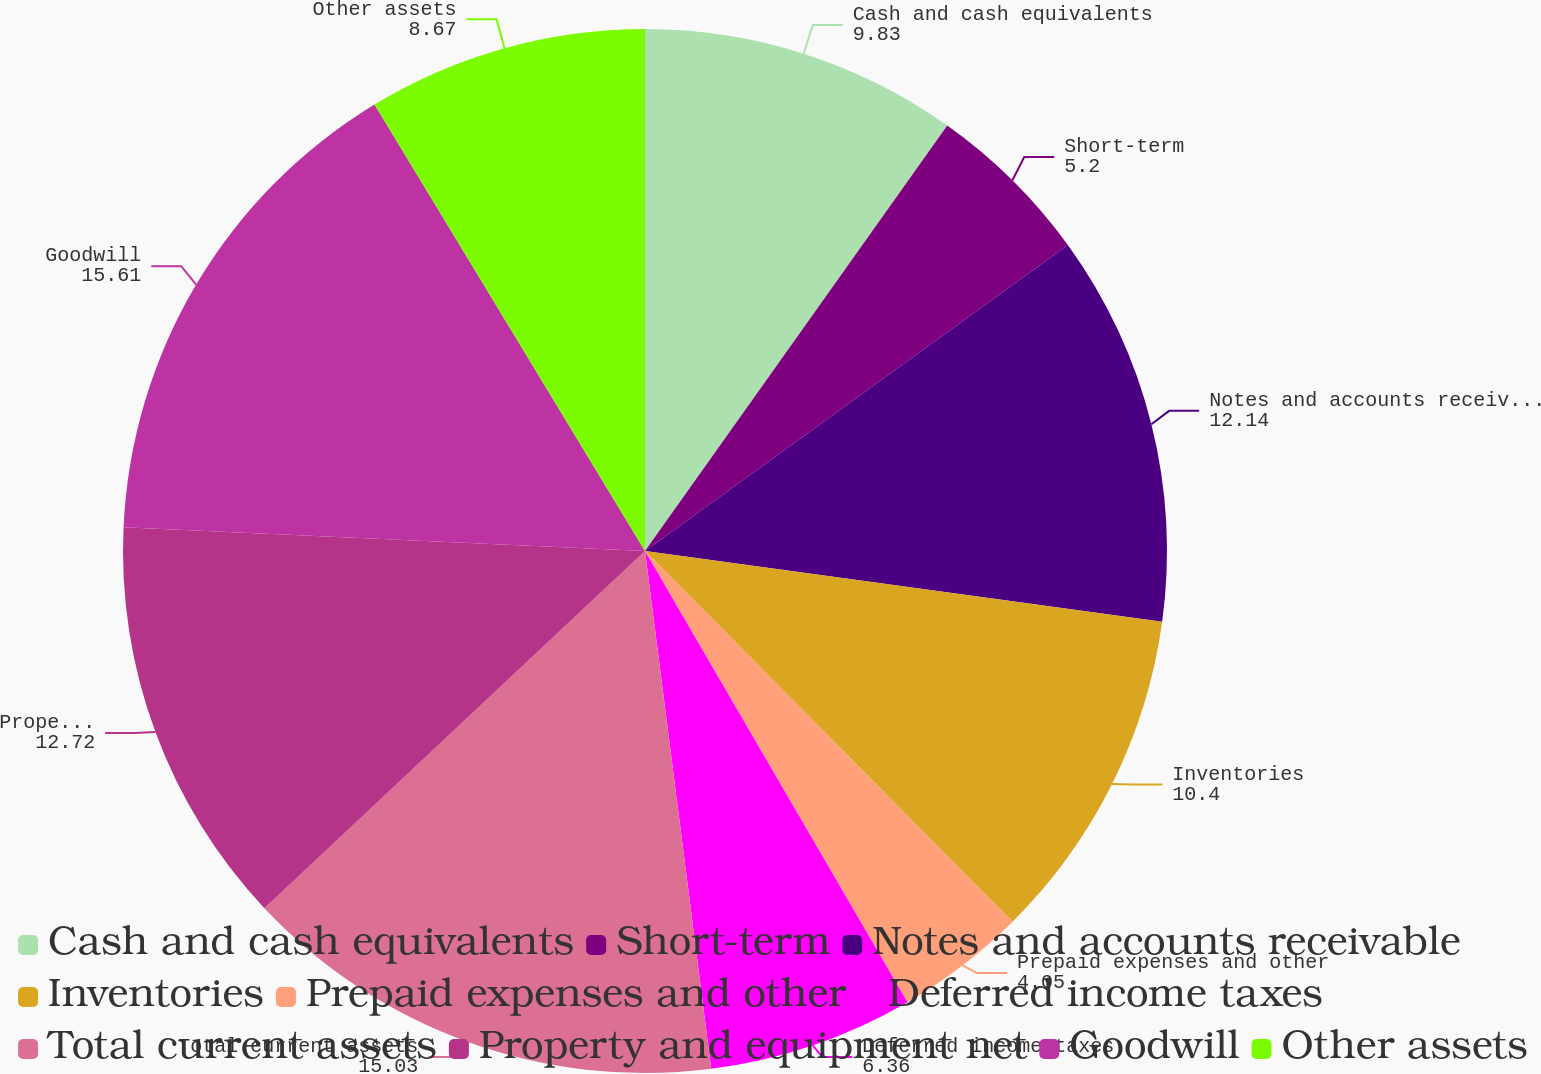<chart> <loc_0><loc_0><loc_500><loc_500><pie_chart><fcel>Cash and cash equivalents<fcel>Short-term<fcel>Notes and accounts receivable<fcel>Inventories<fcel>Prepaid expenses and other<fcel>Deferred income taxes<fcel>Total current assets<fcel>Property and equipment net<fcel>Goodwill<fcel>Other assets<nl><fcel>9.83%<fcel>5.2%<fcel>12.14%<fcel>10.4%<fcel>4.05%<fcel>6.36%<fcel>15.03%<fcel>12.72%<fcel>15.61%<fcel>8.67%<nl></chart> 